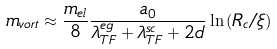Convert formula to latex. <formula><loc_0><loc_0><loc_500><loc_500>m _ { v o r t } \approx \frac { m _ { e l } } { 8 } \frac { a _ { 0 } } { \lambda _ { T F } ^ { e g } + \lambda _ { T F } ^ { s c } + 2 d } \ln { ( R _ { c } / \xi ) }</formula> 